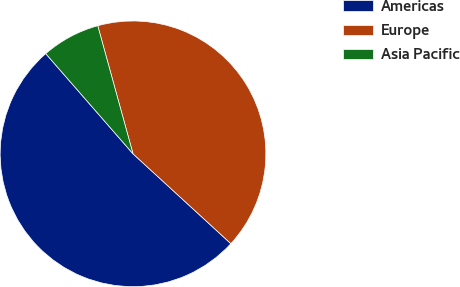Convert chart. <chart><loc_0><loc_0><loc_500><loc_500><pie_chart><fcel>Americas<fcel>Europe<fcel>Asia Pacific<nl><fcel>51.77%<fcel>41.1%<fcel>7.13%<nl></chart> 